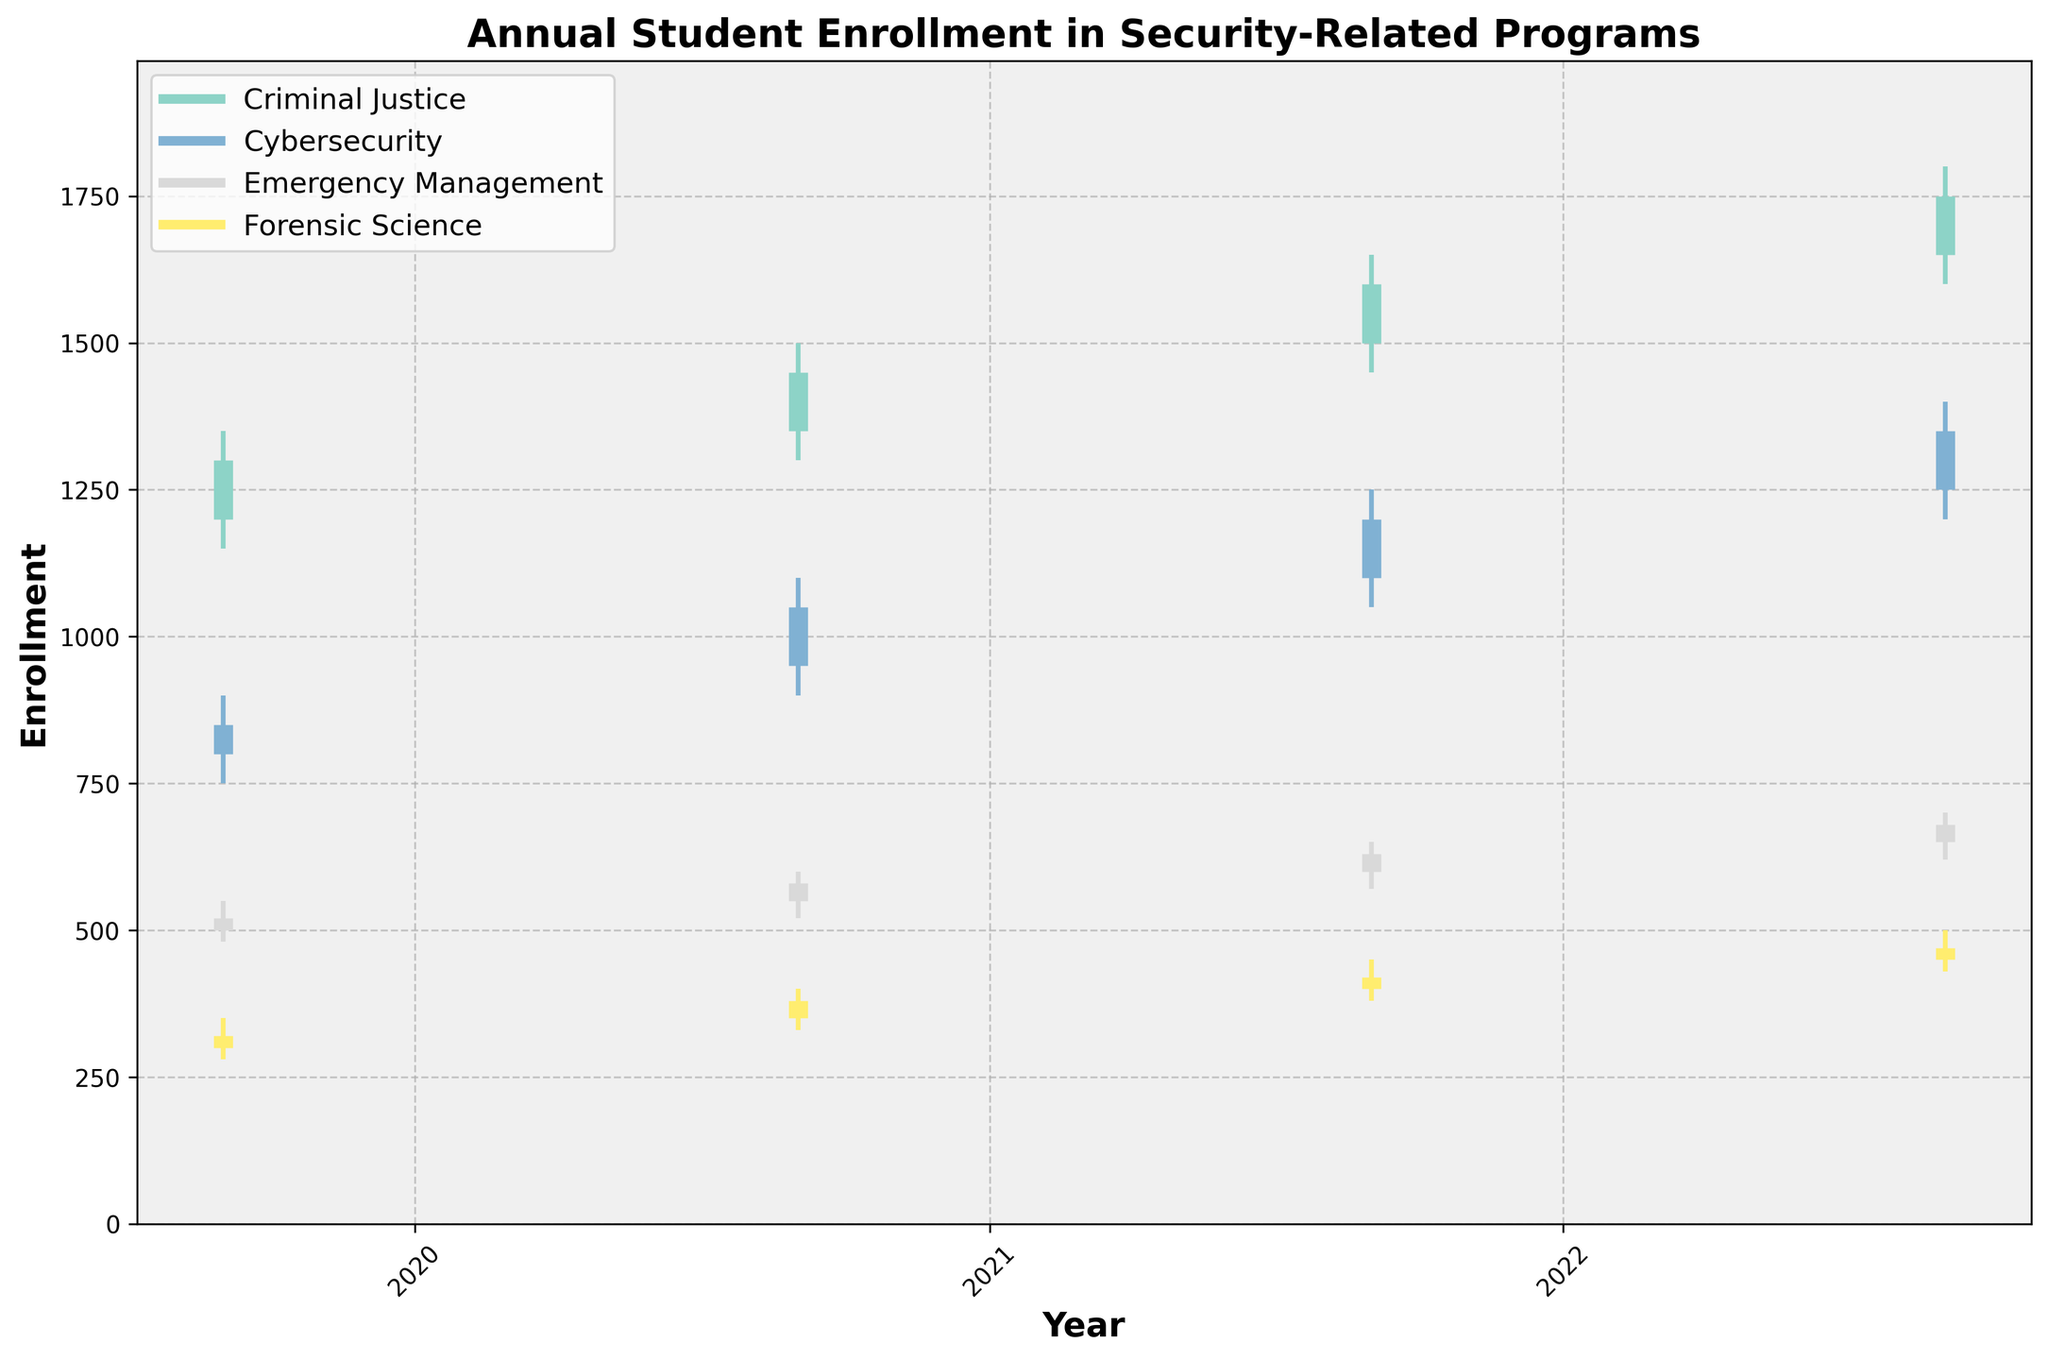What's the title of the figure? The title of the figure is typically located at the top of the chart and summarizes what the visual represents. By looking at the topmost text, we can observe it is "Annual Student Enrollment in Security-Related Programs".
Answer: Annual Student Enrollment in Security-Related Programs How many programs are represented in the figure? To determine the number of programs, look at the legend on the chart which indicates the distinct programs being depicted. The legend shows four distinct labels: Criminal Justice, Cybersecurity, Emergency Management, and Forensic Science.
Answer: Four Which program had the highest closing enrollment in 2022? Check the closing values of each program for the year 2022 on the chart. The closing value is indicated by the upper endpoint of the thick line. The chart shows that Criminal Justice had the highest closing enrollment of 1750 in 2022.
Answer: Criminal Justice What was the opening enrollment for Cybersecurity in 2020? Locate the year 2020 on the x-axis and identify the thick vertical bar corresponding to Cybersecurity. The opening enrollment is shown as the lower endpoint of the thick line. The opening enrollment for Cybersecurity in 2020 was 950.
Answer: 950 How did the highest enrollment for Emergency Management change from 2019 to 2022? Compare the highest (peak) enrollments for Emergency Management in 2019 and 2022. The chart shows the highest enrollment point in 2019 was 550, and in 2022 it was 700. Thus, the highest enrollment increased by 150 (700 - 550).
Answer: Increased by 150 Which program experienced the greatest increase in closing enrollment from 2019 to 2022? Compare the closing enrollments in 2019 and 2022 for each program. Calculate the difference: Criminal Justice (1750-1300=450), Cybersecurity (1350-850=500), Emergency Management (680-520=160), and Forensic Science(470-320=150). Cybersecurity had the greatest increase with a difference of 500.
Answer: Cybersecurity In 2021, which program had the smallest range between its highest and lowest enrollment? For each program in 2021, calculate the range by subtracting the lowest enrollment from the highest enrollment. Criminal Justice (1650-1450=200), Cybersecurity (1250-1050=200), Emergency Management (650-570=80), Forensic Science (450-380=70). Forensic Science has the smallest range of 70.
Answer: Forensic Science Which program had its enrollment always increasing each year from 2019 to 2022? Check the closing values for each year from 2019 to 2022 for each program. Criminal Justice (1300, 1450, 1600, 1750), Cybersecurity (850, 1050, 1200, 1350), Emergency Management (520, 580, 630, 680), Forensic Science (320, 380, 420, 470). All programs have enrollments increasing each year.
Answer: All programs What is the average closing enrollment of Forensic Science from 2019 to 2022? Calculate the average by summing the closing enrollments for Forensic Science over the years and dividing by the count. (320 + 380 + 420 + 470) / 4 = 1590 / 4 = 397.5
Answer: 397.5 What was the enrollment trend for Cybersecurity from 2019 to 2022? Observe the closing enrollments over the four years for Cybersecurity: 850 in 2019, 1050 in 2020, 1200 in 2021, and 1350 in 2022. The trend shows a consistent increase each year.
Answer: Increasing 